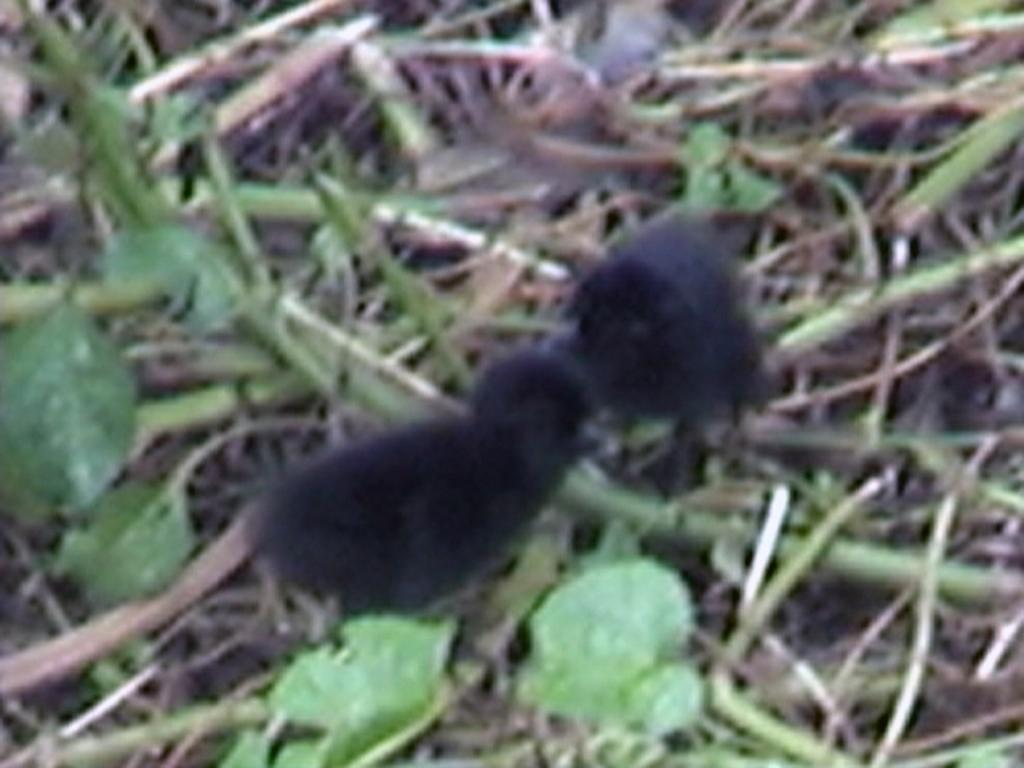What is located in the center of the image? There are birds in the center of the image. What type of vegetation can be seen at the bottom of the image? There is grass visible at the bottom of the image. What type of paste is being distributed by the birds in the image? There is no paste being distributed by the birds in the image; they are simply present in the center of the image. 